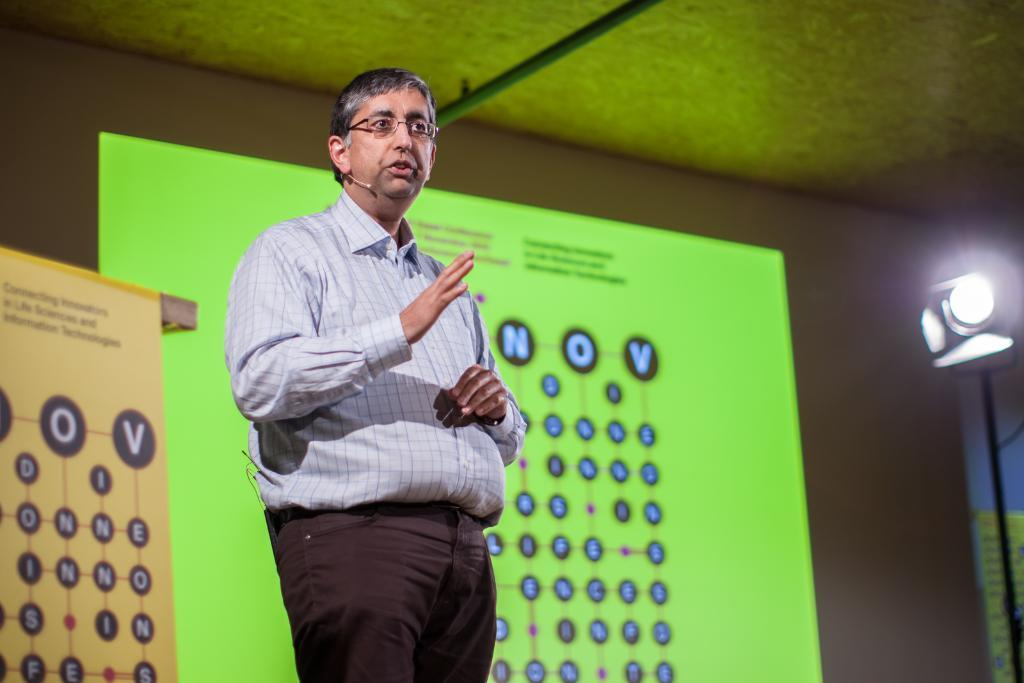What is the man in the image doing? The man is standing and talking in the image. Can you describe the man's appearance? The man is wearing spectacles. What is located beside the man? There is a board beside the man. What can be seen in the background of the image? There is a screen visible in the background of the image. What is the source of light on the right side of the image? There is a focused light on the right side of the image. What type of popcorn is being served during the rain and fog in the image? There is no mention of rain, fog, or popcorn in the image. The image only shows a man standing and talking with a board beside him, a screen in the background, and a focused light on the right side. 